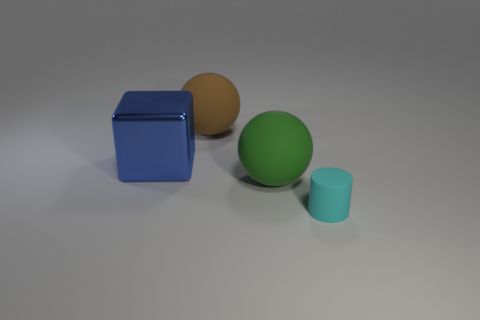What number of things are large purple things or big objects? In the image, there are no large purple objects; however, if we consider big objects, there is one large blue cube. 